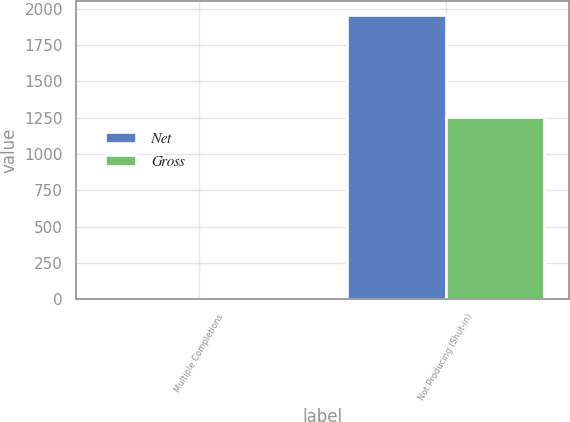Convert chart. <chart><loc_0><loc_0><loc_500><loc_500><stacked_bar_chart><ecel><fcel>Multiple Completions<fcel>Not Producing (Shut-in)<nl><fcel>Net<fcel>7<fcel>1954<nl><fcel>Gross<fcel>4.6<fcel>1256.9<nl></chart> 